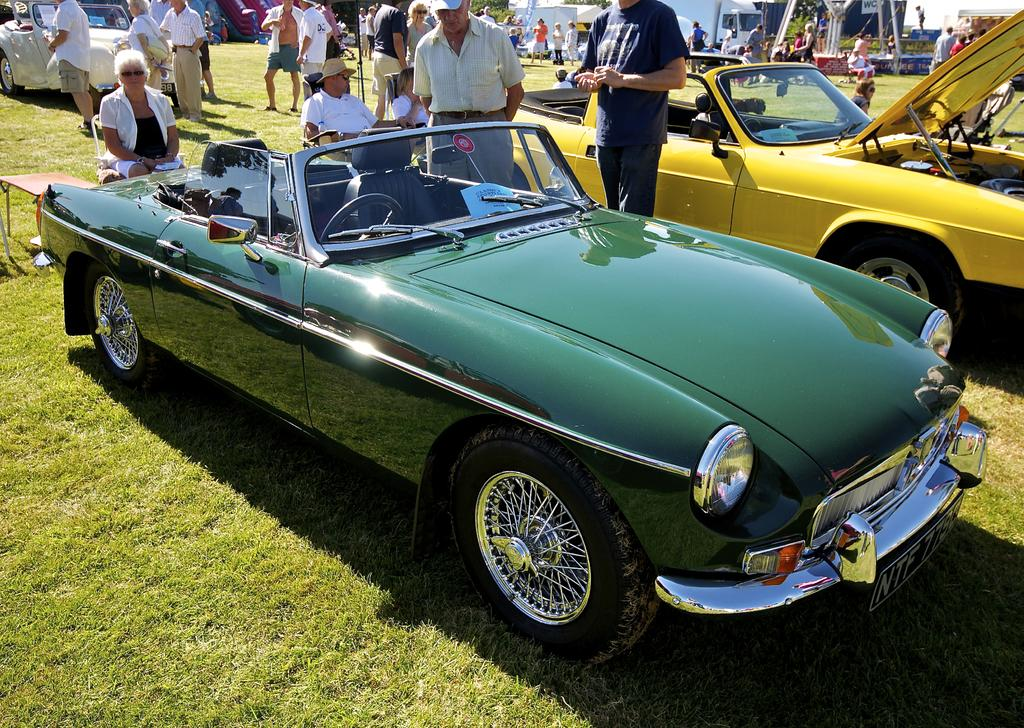What can be seen in the image besides the groups of people? There are vehicles in the image. What are the people doing in the image? Some people are sitting on chairs, and there are groups of people on the grass. Can you describe the position of the vehicles in the image? There is another vehicle behind the people, and some vehicles can be seen in the image. What objects are visible behind the people? There are objects visible behind the people. What type of pets can be seen on the people's chins in the image? There are no pets visible on the people's chins in the image. How many knees are visible in the image? The number of knees visible in the image cannot be determined from the provided facts. 